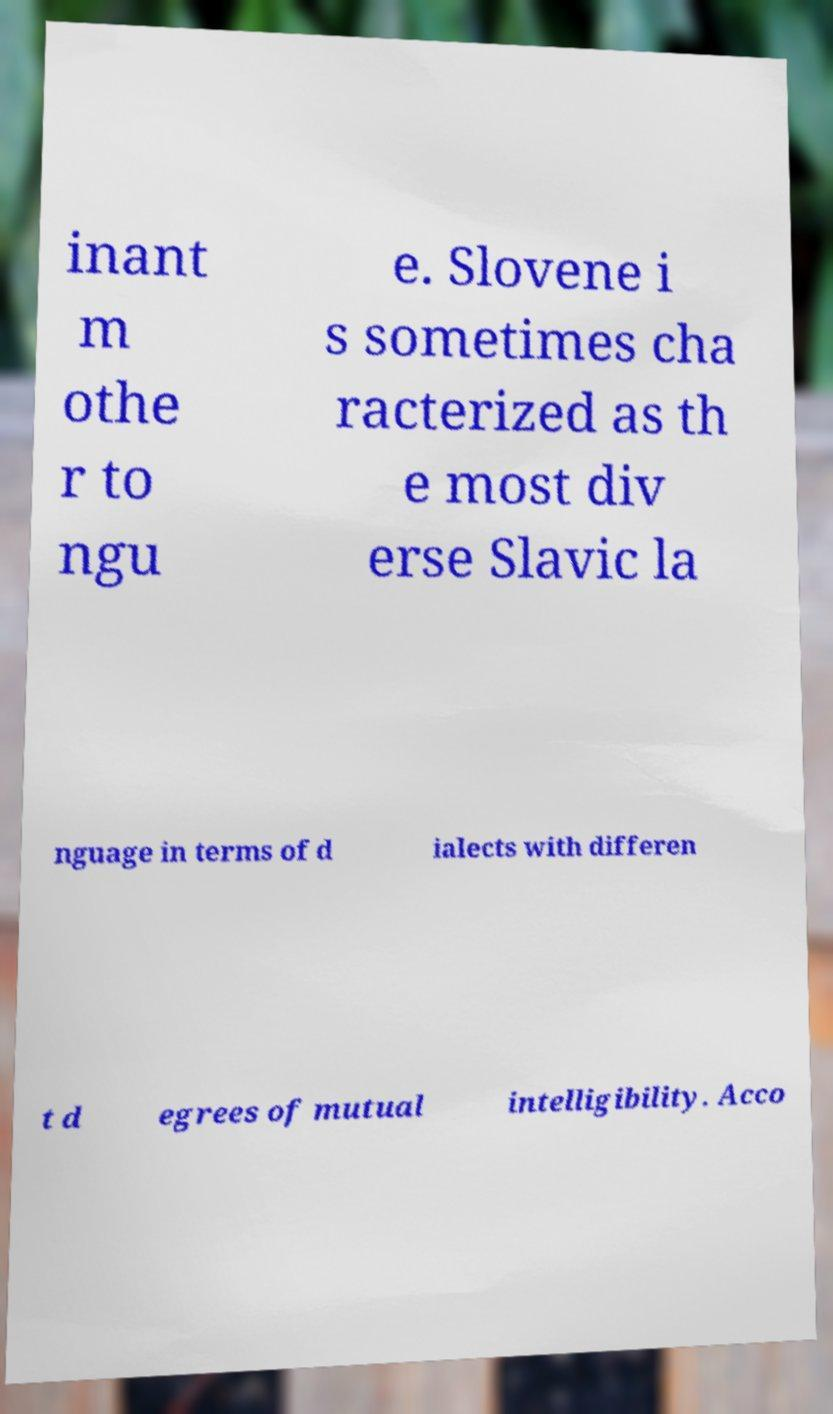There's text embedded in this image that I need extracted. Can you transcribe it verbatim? inant m othe r to ngu e. Slovene i s sometimes cha racterized as th e most div erse Slavic la nguage in terms of d ialects with differen t d egrees of mutual intelligibility. Acco 